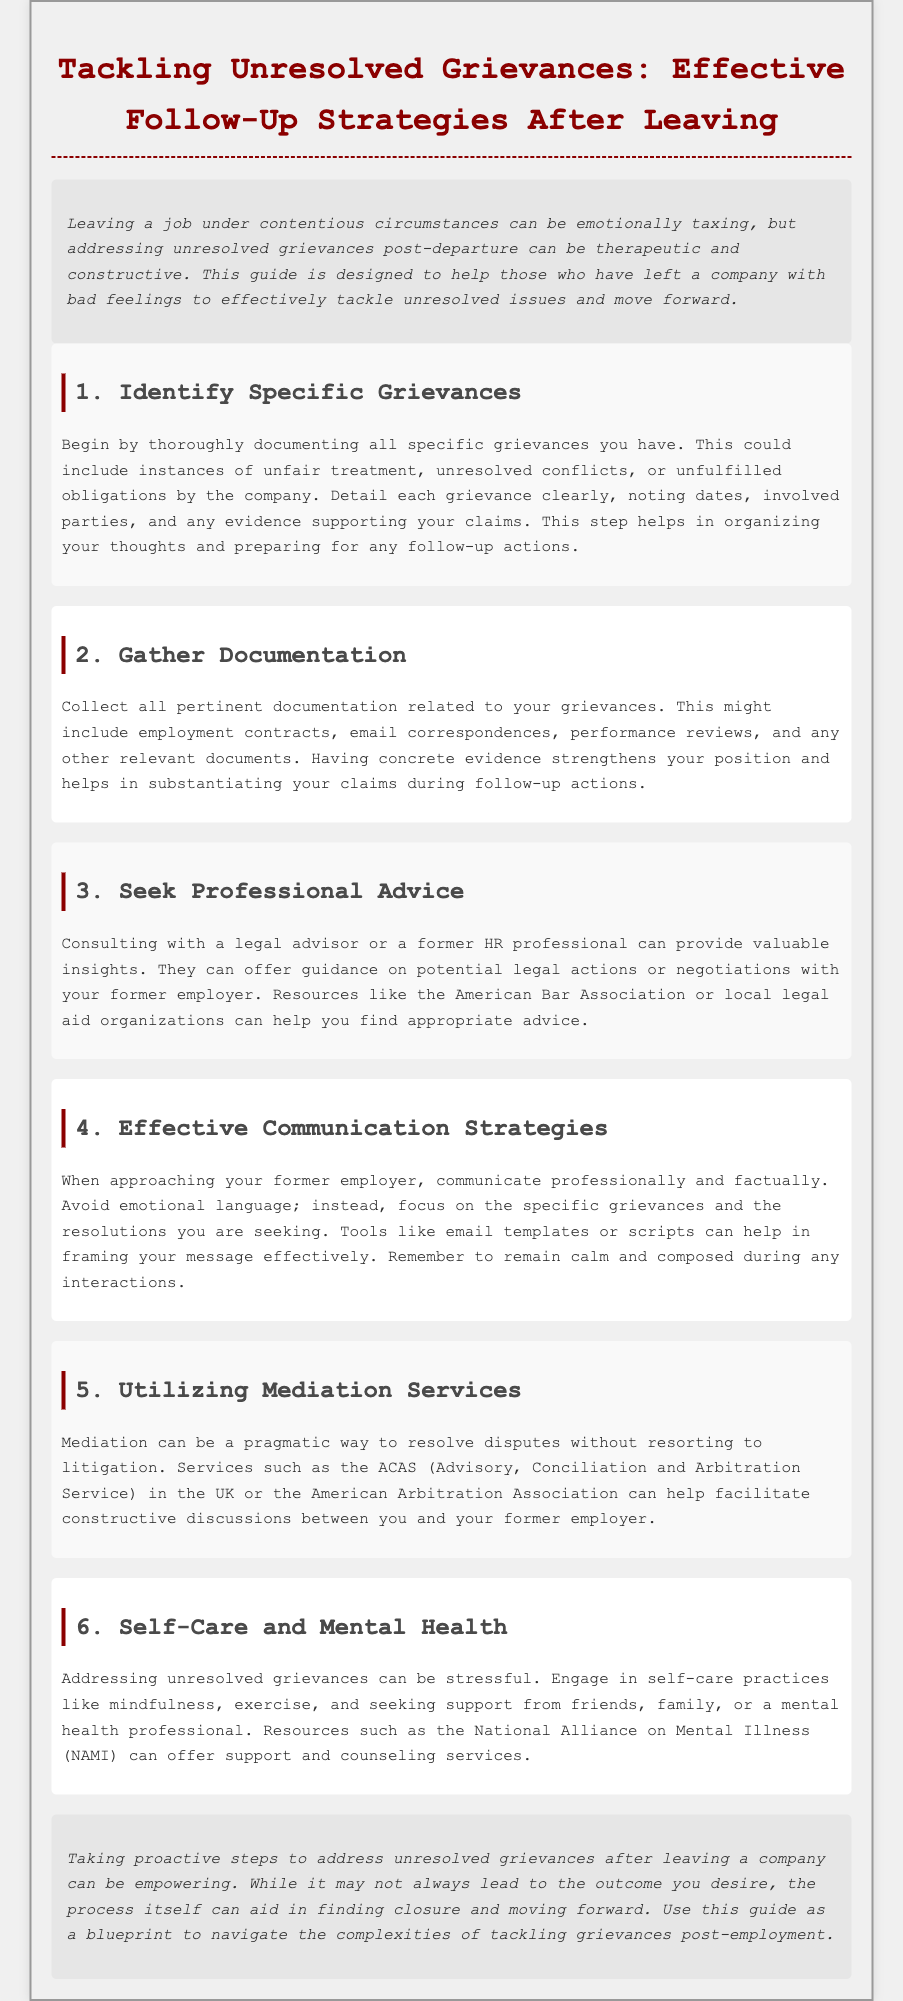what is the title of the guide? The title appears at the top of the document and summarizes the main subject matter.
Answer: Tackling Unresolved Grievances: Effective Follow-Up Strategies After Leaving what is the first step in addressing grievances? The first step is outlined in the initial section, providing a clear action point for readers.
Answer: Identify Specific Grievances what legal resources are mentioned for seeking advice? The document lists specific organizations that can help individuals seeking legal advice.
Answer: American Bar Association what is one strategy for effective communication? The guide highlights a key approach to communication that can aid in resolving grievances.
Answer: Avoid emotional language what is a recommended self-care practice? The document suggests various practices for maintaining mental health while addressing grievances.
Answer: Mindfulness 